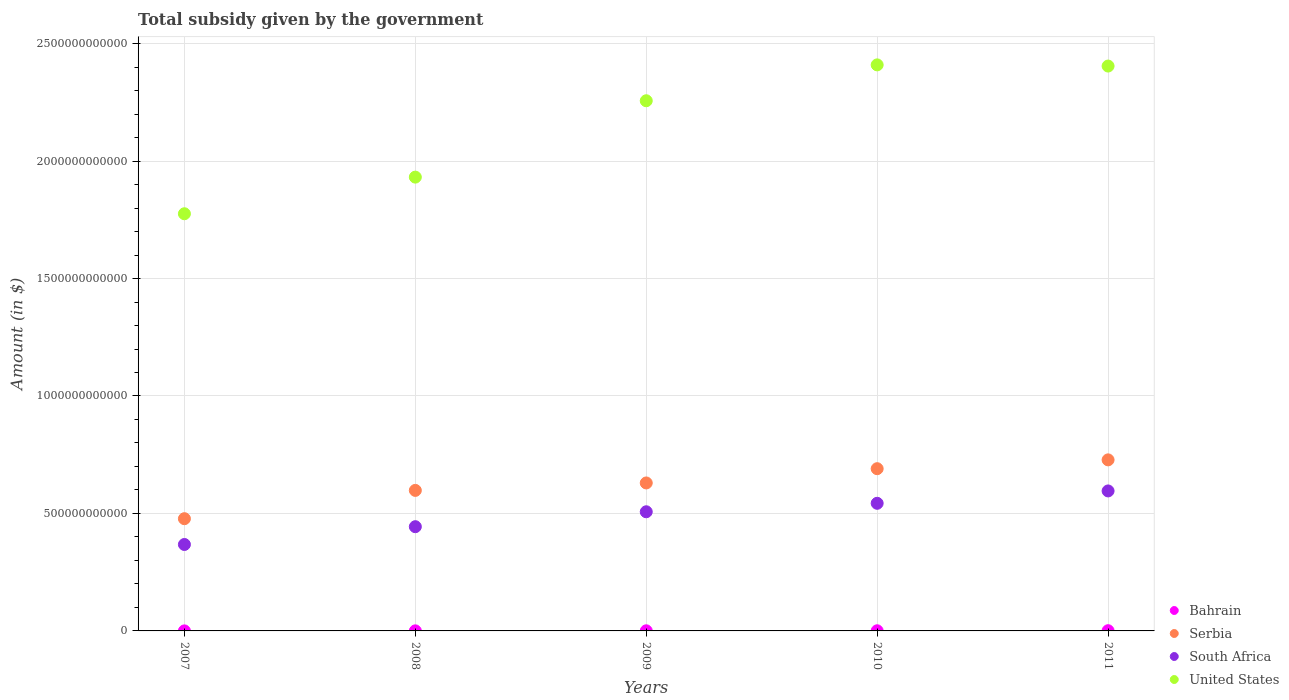Is the number of dotlines equal to the number of legend labels?
Provide a succinct answer. Yes. What is the total revenue collected by the government in Bahrain in 2007?
Offer a very short reply. 1.33e+08. Across all years, what is the maximum total revenue collected by the government in Bahrain?
Provide a short and direct response. 9.39e+08. Across all years, what is the minimum total revenue collected by the government in Serbia?
Ensure brevity in your answer.  4.78e+11. In which year was the total revenue collected by the government in United States maximum?
Keep it short and to the point. 2010. In which year was the total revenue collected by the government in South Africa minimum?
Provide a short and direct response. 2007. What is the total total revenue collected by the government in Serbia in the graph?
Your response must be concise. 3.12e+12. What is the difference between the total revenue collected by the government in Bahrain in 2007 and that in 2011?
Provide a short and direct response. -8.07e+08. What is the difference between the total revenue collected by the government in United States in 2010 and the total revenue collected by the government in Serbia in 2008?
Provide a short and direct response. 1.81e+12. What is the average total revenue collected by the government in United States per year?
Keep it short and to the point. 2.16e+12. In the year 2011, what is the difference between the total revenue collected by the government in South Africa and total revenue collected by the government in United States?
Provide a short and direct response. -1.81e+12. In how many years, is the total revenue collected by the government in South Africa greater than 900000000000 $?
Offer a terse response. 0. What is the ratio of the total revenue collected by the government in South Africa in 2007 to that in 2011?
Offer a very short reply. 0.62. Is the total revenue collected by the government in United States in 2007 less than that in 2011?
Your answer should be very brief. Yes. What is the difference between the highest and the lowest total revenue collected by the government in Bahrain?
Your answer should be very brief. 8.07e+08. Is the sum of the total revenue collected by the government in Bahrain in 2007 and 2010 greater than the maximum total revenue collected by the government in United States across all years?
Provide a succinct answer. No. Is the total revenue collected by the government in United States strictly less than the total revenue collected by the government in Serbia over the years?
Give a very brief answer. No. How many dotlines are there?
Your answer should be very brief. 4. What is the difference between two consecutive major ticks on the Y-axis?
Keep it short and to the point. 5.00e+11. Are the values on the major ticks of Y-axis written in scientific E-notation?
Offer a terse response. No. Does the graph contain any zero values?
Offer a terse response. No. Does the graph contain grids?
Give a very brief answer. Yes. Where does the legend appear in the graph?
Your answer should be very brief. Bottom right. How are the legend labels stacked?
Make the answer very short. Vertical. What is the title of the graph?
Provide a short and direct response. Total subsidy given by the government. Does "Kosovo" appear as one of the legend labels in the graph?
Your answer should be very brief. No. What is the label or title of the X-axis?
Offer a terse response. Years. What is the label or title of the Y-axis?
Your answer should be compact. Amount (in $). What is the Amount (in $) of Bahrain in 2007?
Ensure brevity in your answer.  1.33e+08. What is the Amount (in $) in Serbia in 2007?
Make the answer very short. 4.78e+11. What is the Amount (in $) in South Africa in 2007?
Your answer should be compact. 3.68e+11. What is the Amount (in $) in United States in 2007?
Offer a very short reply. 1.78e+12. What is the Amount (in $) of Bahrain in 2008?
Provide a short and direct response. 3.10e+08. What is the Amount (in $) in Serbia in 2008?
Make the answer very short. 5.98e+11. What is the Amount (in $) in South Africa in 2008?
Offer a very short reply. 4.44e+11. What is the Amount (in $) in United States in 2008?
Make the answer very short. 1.93e+12. What is the Amount (in $) in Bahrain in 2009?
Provide a short and direct response. 5.10e+08. What is the Amount (in $) in Serbia in 2009?
Keep it short and to the point. 6.30e+11. What is the Amount (in $) of South Africa in 2009?
Offer a terse response. 5.07e+11. What is the Amount (in $) of United States in 2009?
Offer a very short reply. 2.26e+12. What is the Amount (in $) of Bahrain in 2010?
Offer a terse response. 6.04e+08. What is the Amount (in $) in Serbia in 2010?
Your answer should be compact. 6.91e+11. What is the Amount (in $) of South Africa in 2010?
Your answer should be compact. 5.43e+11. What is the Amount (in $) of United States in 2010?
Make the answer very short. 2.41e+12. What is the Amount (in $) in Bahrain in 2011?
Your answer should be very brief. 9.39e+08. What is the Amount (in $) of Serbia in 2011?
Offer a terse response. 7.28e+11. What is the Amount (in $) in South Africa in 2011?
Ensure brevity in your answer.  5.96e+11. What is the Amount (in $) of United States in 2011?
Your response must be concise. 2.40e+12. Across all years, what is the maximum Amount (in $) of Bahrain?
Offer a very short reply. 9.39e+08. Across all years, what is the maximum Amount (in $) of Serbia?
Make the answer very short. 7.28e+11. Across all years, what is the maximum Amount (in $) of South Africa?
Provide a succinct answer. 5.96e+11. Across all years, what is the maximum Amount (in $) of United States?
Offer a very short reply. 2.41e+12. Across all years, what is the minimum Amount (in $) of Bahrain?
Keep it short and to the point. 1.33e+08. Across all years, what is the minimum Amount (in $) of Serbia?
Give a very brief answer. 4.78e+11. Across all years, what is the minimum Amount (in $) in South Africa?
Provide a succinct answer. 3.68e+11. Across all years, what is the minimum Amount (in $) of United States?
Ensure brevity in your answer.  1.78e+12. What is the total Amount (in $) of Bahrain in the graph?
Provide a short and direct response. 2.50e+09. What is the total Amount (in $) in Serbia in the graph?
Provide a short and direct response. 3.12e+12. What is the total Amount (in $) of South Africa in the graph?
Ensure brevity in your answer.  2.46e+12. What is the total Amount (in $) in United States in the graph?
Your answer should be compact. 1.08e+13. What is the difference between the Amount (in $) in Bahrain in 2007 and that in 2008?
Your answer should be compact. -1.78e+08. What is the difference between the Amount (in $) in Serbia in 2007 and that in 2008?
Your answer should be very brief. -1.20e+11. What is the difference between the Amount (in $) of South Africa in 2007 and that in 2008?
Ensure brevity in your answer.  -7.57e+1. What is the difference between the Amount (in $) of United States in 2007 and that in 2008?
Your answer should be compact. -1.56e+11. What is the difference between the Amount (in $) in Bahrain in 2007 and that in 2009?
Your answer should be very brief. -3.78e+08. What is the difference between the Amount (in $) in Serbia in 2007 and that in 2009?
Provide a succinct answer. -1.52e+11. What is the difference between the Amount (in $) of South Africa in 2007 and that in 2009?
Your response must be concise. -1.39e+11. What is the difference between the Amount (in $) in United States in 2007 and that in 2009?
Offer a very short reply. -4.81e+11. What is the difference between the Amount (in $) in Bahrain in 2007 and that in 2010?
Ensure brevity in your answer.  -4.71e+08. What is the difference between the Amount (in $) in Serbia in 2007 and that in 2010?
Your response must be concise. -2.13e+11. What is the difference between the Amount (in $) in South Africa in 2007 and that in 2010?
Give a very brief answer. -1.75e+11. What is the difference between the Amount (in $) in United States in 2007 and that in 2010?
Your answer should be very brief. -6.34e+11. What is the difference between the Amount (in $) in Bahrain in 2007 and that in 2011?
Your answer should be compact. -8.07e+08. What is the difference between the Amount (in $) of Serbia in 2007 and that in 2011?
Offer a very short reply. -2.50e+11. What is the difference between the Amount (in $) of South Africa in 2007 and that in 2011?
Your answer should be compact. -2.28e+11. What is the difference between the Amount (in $) of United States in 2007 and that in 2011?
Your response must be concise. -6.29e+11. What is the difference between the Amount (in $) in Bahrain in 2008 and that in 2009?
Your answer should be compact. -2.00e+08. What is the difference between the Amount (in $) of Serbia in 2008 and that in 2009?
Ensure brevity in your answer.  -3.17e+1. What is the difference between the Amount (in $) in South Africa in 2008 and that in 2009?
Keep it short and to the point. -6.35e+1. What is the difference between the Amount (in $) of United States in 2008 and that in 2009?
Offer a terse response. -3.25e+11. What is the difference between the Amount (in $) of Bahrain in 2008 and that in 2010?
Give a very brief answer. -2.94e+08. What is the difference between the Amount (in $) of Serbia in 2008 and that in 2010?
Make the answer very short. -9.24e+1. What is the difference between the Amount (in $) in South Africa in 2008 and that in 2010?
Provide a succinct answer. -9.96e+1. What is the difference between the Amount (in $) in United States in 2008 and that in 2010?
Give a very brief answer. -4.78e+11. What is the difference between the Amount (in $) in Bahrain in 2008 and that in 2011?
Make the answer very short. -6.29e+08. What is the difference between the Amount (in $) of Serbia in 2008 and that in 2011?
Your answer should be compact. -1.30e+11. What is the difference between the Amount (in $) of South Africa in 2008 and that in 2011?
Provide a short and direct response. -1.52e+11. What is the difference between the Amount (in $) of United States in 2008 and that in 2011?
Make the answer very short. -4.73e+11. What is the difference between the Amount (in $) of Bahrain in 2009 and that in 2010?
Give a very brief answer. -9.36e+07. What is the difference between the Amount (in $) in Serbia in 2009 and that in 2010?
Ensure brevity in your answer.  -6.07e+1. What is the difference between the Amount (in $) of South Africa in 2009 and that in 2010?
Give a very brief answer. -3.61e+1. What is the difference between the Amount (in $) of United States in 2009 and that in 2010?
Offer a terse response. -1.53e+11. What is the difference between the Amount (in $) of Bahrain in 2009 and that in 2011?
Keep it short and to the point. -4.29e+08. What is the difference between the Amount (in $) of Serbia in 2009 and that in 2011?
Provide a succinct answer. -9.83e+1. What is the difference between the Amount (in $) in South Africa in 2009 and that in 2011?
Your answer should be very brief. -8.87e+1. What is the difference between the Amount (in $) of United States in 2009 and that in 2011?
Keep it short and to the point. -1.48e+11. What is the difference between the Amount (in $) in Bahrain in 2010 and that in 2011?
Provide a short and direct response. -3.35e+08. What is the difference between the Amount (in $) in Serbia in 2010 and that in 2011?
Your answer should be compact. -3.75e+1. What is the difference between the Amount (in $) of South Africa in 2010 and that in 2011?
Offer a very short reply. -5.26e+1. What is the difference between the Amount (in $) in United States in 2010 and that in 2011?
Offer a very short reply. 5.00e+09. What is the difference between the Amount (in $) of Bahrain in 2007 and the Amount (in $) of Serbia in 2008?
Provide a short and direct response. -5.98e+11. What is the difference between the Amount (in $) of Bahrain in 2007 and the Amount (in $) of South Africa in 2008?
Your response must be concise. -4.44e+11. What is the difference between the Amount (in $) in Bahrain in 2007 and the Amount (in $) in United States in 2008?
Keep it short and to the point. -1.93e+12. What is the difference between the Amount (in $) of Serbia in 2007 and the Amount (in $) of South Africa in 2008?
Give a very brief answer. 3.41e+1. What is the difference between the Amount (in $) of Serbia in 2007 and the Amount (in $) of United States in 2008?
Give a very brief answer. -1.45e+12. What is the difference between the Amount (in $) of South Africa in 2007 and the Amount (in $) of United States in 2008?
Keep it short and to the point. -1.56e+12. What is the difference between the Amount (in $) in Bahrain in 2007 and the Amount (in $) in Serbia in 2009?
Provide a short and direct response. -6.30e+11. What is the difference between the Amount (in $) of Bahrain in 2007 and the Amount (in $) of South Africa in 2009?
Provide a short and direct response. -5.07e+11. What is the difference between the Amount (in $) in Bahrain in 2007 and the Amount (in $) in United States in 2009?
Provide a short and direct response. -2.26e+12. What is the difference between the Amount (in $) of Serbia in 2007 and the Amount (in $) of South Africa in 2009?
Your response must be concise. -2.94e+1. What is the difference between the Amount (in $) in Serbia in 2007 and the Amount (in $) in United States in 2009?
Make the answer very short. -1.78e+12. What is the difference between the Amount (in $) in South Africa in 2007 and the Amount (in $) in United States in 2009?
Your response must be concise. -1.89e+12. What is the difference between the Amount (in $) in Bahrain in 2007 and the Amount (in $) in Serbia in 2010?
Your answer should be compact. -6.90e+11. What is the difference between the Amount (in $) in Bahrain in 2007 and the Amount (in $) in South Africa in 2010?
Ensure brevity in your answer.  -5.43e+11. What is the difference between the Amount (in $) in Bahrain in 2007 and the Amount (in $) in United States in 2010?
Your answer should be compact. -2.41e+12. What is the difference between the Amount (in $) of Serbia in 2007 and the Amount (in $) of South Africa in 2010?
Offer a very short reply. -6.55e+1. What is the difference between the Amount (in $) of Serbia in 2007 and the Amount (in $) of United States in 2010?
Provide a succinct answer. -1.93e+12. What is the difference between the Amount (in $) in South Africa in 2007 and the Amount (in $) in United States in 2010?
Make the answer very short. -2.04e+12. What is the difference between the Amount (in $) of Bahrain in 2007 and the Amount (in $) of Serbia in 2011?
Your answer should be very brief. -7.28e+11. What is the difference between the Amount (in $) of Bahrain in 2007 and the Amount (in $) of South Africa in 2011?
Make the answer very short. -5.96e+11. What is the difference between the Amount (in $) in Bahrain in 2007 and the Amount (in $) in United States in 2011?
Provide a short and direct response. -2.40e+12. What is the difference between the Amount (in $) of Serbia in 2007 and the Amount (in $) of South Africa in 2011?
Provide a succinct answer. -1.18e+11. What is the difference between the Amount (in $) in Serbia in 2007 and the Amount (in $) in United States in 2011?
Your response must be concise. -1.93e+12. What is the difference between the Amount (in $) in South Africa in 2007 and the Amount (in $) in United States in 2011?
Keep it short and to the point. -2.04e+12. What is the difference between the Amount (in $) in Bahrain in 2008 and the Amount (in $) in Serbia in 2009?
Give a very brief answer. -6.30e+11. What is the difference between the Amount (in $) in Bahrain in 2008 and the Amount (in $) in South Africa in 2009?
Ensure brevity in your answer.  -5.07e+11. What is the difference between the Amount (in $) in Bahrain in 2008 and the Amount (in $) in United States in 2009?
Keep it short and to the point. -2.26e+12. What is the difference between the Amount (in $) of Serbia in 2008 and the Amount (in $) of South Africa in 2009?
Give a very brief answer. 9.10e+1. What is the difference between the Amount (in $) of Serbia in 2008 and the Amount (in $) of United States in 2009?
Provide a short and direct response. -1.66e+12. What is the difference between the Amount (in $) of South Africa in 2008 and the Amount (in $) of United States in 2009?
Keep it short and to the point. -1.81e+12. What is the difference between the Amount (in $) in Bahrain in 2008 and the Amount (in $) in Serbia in 2010?
Give a very brief answer. -6.90e+11. What is the difference between the Amount (in $) in Bahrain in 2008 and the Amount (in $) in South Africa in 2010?
Give a very brief answer. -5.43e+11. What is the difference between the Amount (in $) in Bahrain in 2008 and the Amount (in $) in United States in 2010?
Provide a succinct answer. -2.41e+12. What is the difference between the Amount (in $) of Serbia in 2008 and the Amount (in $) of South Africa in 2010?
Your response must be concise. 5.49e+1. What is the difference between the Amount (in $) in Serbia in 2008 and the Amount (in $) in United States in 2010?
Ensure brevity in your answer.  -1.81e+12. What is the difference between the Amount (in $) in South Africa in 2008 and the Amount (in $) in United States in 2010?
Your answer should be compact. -1.97e+12. What is the difference between the Amount (in $) of Bahrain in 2008 and the Amount (in $) of Serbia in 2011?
Your answer should be compact. -7.28e+11. What is the difference between the Amount (in $) of Bahrain in 2008 and the Amount (in $) of South Africa in 2011?
Offer a terse response. -5.96e+11. What is the difference between the Amount (in $) of Bahrain in 2008 and the Amount (in $) of United States in 2011?
Keep it short and to the point. -2.40e+12. What is the difference between the Amount (in $) of Serbia in 2008 and the Amount (in $) of South Africa in 2011?
Your response must be concise. 2.31e+09. What is the difference between the Amount (in $) in Serbia in 2008 and the Amount (in $) in United States in 2011?
Make the answer very short. -1.81e+12. What is the difference between the Amount (in $) in South Africa in 2008 and the Amount (in $) in United States in 2011?
Keep it short and to the point. -1.96e+12. What is the difference between the Amount (in $) in Bahrain in 2009 and the Amount (in $) in Serbia in 2010?
Offer a terse response. -6.90e+11. What is the difference between the Amount (in $) in Bahrain in 2009 and the Amount (in $) in South Africa in 2010?
Provide a succinct answer. -5.43e+11. What is the difference between the Amount (in $) of Bahrain in 2009 and the Amount (in $) of United States in 2010?
Your answer should be compact. -2.41e+12. What is the difference between the Amount (in $) in Serbia in 2009 and the Amount (in $) in South Africa in 2010?
Offer a terse response. 8.66e+1. What is the difference between the Amount (in $) in Serbia in 2009 and the Amount (in $) in United States in 2010?
Make the answer very short. -1.78e+12. What is the difference between the Amount (in $) in South Africa in 2009 and the Amount (in $) in United States in 2010?
Offer a terse response. -1.90e+12. What is the difference between the Amount (in $) in Bahrain in 2009 and the Amount (in $) in Serbia in 2011?
Make the answer very short. -7.28e+11. What is the difference between the Amount (in $) of Bahrain in 2009 and the Amount (in $) of South Africa in 2011?
Make the answer very short. -5.95e+11. What is the difference between the Amount (in $) of Bahrain in 2009 and the Amount (in $) of United States in 2011?
Your answer should be very brief. -2.40e+12. What is the difference between the Amount (in $) of Serbia in 2009 and the Amount (in $) of South Africa in 2011?
Provide a succinct answer. 3.40e+1. What is the difference between the Amount (in $) of Serbia in 2009 and the Amount (in $) of United States in 2011?
Keep it short and to the point. -1.77e+12. What is the difference between the Amount (in $) of South Africa in 2009 and the Amount (in $) of United States in 2011?
Offer a very short reply. -1.90e+12. What is the difference between the Amount (in $) of Bahrain in 2010 and the Amount (in $) of Serbia in 2011?
Offer a terse response. -7.27e+11. What is the difference between the Amount (in $) of Bahrain in 2010 and the Amount (in $) of South Africa in 2011?
Ensure brevity in your answer.  -5.95e+11. What is the difference between the Amount (in $) of Bahrain in 2010 and the Amount (in $) of United States in 2011?
Keep it short and to the point. -2.40e+12. What is the difference between the Amount (in $) of Serbia in 2010 and the Amount (in $) of South Africa in 2011?
Offer a very short reply. 9.47e+1. What is the difference between the Amount (in $) in Serbia in 2010 and the Amount (in $) in United States in 2011?
Offer a terse response. -1.71e+12. What is the difference between the Amount (in $) of South Africa in 2010 and the Amount (in $) of United States in 2011?
Provide a succinct answer. -1.86e+12. What is the average Amount (in $) of Bahrain per year?
Offer a terse response. 4.99e+08. What is the average Amount (in $) in Serbia per year?
Your response must be concise. 6.25e+11. What is the average Amount (in $) of South Africa per year?
Make the answer very short. 4.92e+11. What is the average Amount (in $) of United States per year?
Keep it short and to the point. 2.16e+12. In the year 2007, what is the difference between the Amount (in $) of Bahrain and Amount (in $) of Serbia?
Provide a succinct answer. -4.78e+11. In the year 2007, what is the difference between the Amount (in $) of Bahrain and Amount (in $) of South Africa?
Give a very brief answer. -3.68e+11. In the year 2007, what is the difference between the Amount (in $) in Bahrain and Amount (in $) in United States?
Keep it short and to the point. -1.78e+12. In the year 2007, what is the difference between the Amount (in $) in Serbia and Amount (in $) in South Africa?
Your response must be concise. 1.10e+11. In the year 2007, what is the difference between the Amount (in $) of Serbia and Amount (in $) of United States?
Provide a short and direct response. -1.30e+12. In the year 2007, what is the difference between the Amount (in $) of South Africa and Amount (in $) of United States?
Ensure brevity in your answer.  -1.41e+12. In the year 2008, what is the difference between the Amount (in $) in Bahrain and Amount (in $) in Serbia?
Provide a succinct answer. -5.98e+11. In the year 2008, what is the difference between the Amount (in $) in Bahrain and Amount (in $) in South Africa?
Give a very brief answer. -4.43e+11. In the year 2008, what is the difference between the Amount (in $) in Bahrain and Amount (in $) in United States?
Offer a terse response. -1.93e+12. In the year 2008, what is the difference between the Amount (in $) of Serbia and Amount (in $) of South Africa?
Make the answer very short. 1.55e+11. In the year 2008, what is the difference between the Amount (in $) in Serbia and Amount (in $) in United States?
Your answer should be compact. -1.33e+12. In the year 2008, what is the difference between the Amount (in $) of South Africa and Amount (in $) of United States?
Ensure brevity in your answer.  -1.49e+12. In the year 2009, what is the difference between the Amount (in $) of Bahrain and Amount (in $) of Serbia?
Offer a very short reply. -6.29e+11. In the year 2009, what is the difference between the Amount (in $) of Bahrain and Amount (in $) of South Africa?
Your answer should be compact. -5.07e+11. In the year 2009, what is the difference between the Amount (in $) of Bahrain and Amount (in $) of United States?
Provide a succinct answer. -2.26e+12. In the year 2009, what is the difference between the Amount (in $) in Serbia and Amount (in $) in South Africa?
Your response must be concise. 1.23e+11. In the year 2009, what is the difference between the Amount (in $) of Serbia and Amount (in $) of United States?
Offer a very short reply. -1.63e+12. In the year 2009, what is the difference between the Amount (in $) in South Africa and Amount (in $) in United States?
Offer a very short reply. -1.75e+12. In the year 2010, what is the difference between the Amount (in $) in Bahrain and Amount (in $) in Serbia?
Provide a short and direct response. -6.90e+11. In the year 2010, what is the difference between the Amount (in $) of Bahrain and Amount (in $) of South Africa?
Provide a succinct answer. -5.43e+11. In the year 2010, what is the difference between the Amount (in $) in Bahrain and Amount (in $) in United States?
Ensure brevity in your answer.  -2.41e+12. In the year 2010, what is the difference between the Amount (in $) in Serbia and Amount (in $) in South Africa?
Your answer should be very brief. 1.47e+11. In the year 2010, what is the difference between the Amount (in $) in Serbia and Amount (in $) in United States?
Ensure brevity in your answer.  -1.72e+12. In the year 2010, what is the difference between the Amount (in $) of South Africa and Amount (in $) of United States?
Offer a terse response. -1.87e+12. In the year 2011, what is the difference between the Amount (in $) in Bahrain and Amount (in $) in Serbia?
Your answer should be compact. -7.27e+11. In the year 2011, what is the difference between the Amount (in $) in Bahrain and Amount (in $) in South Africa?
Keep it short and to the point. -5.95e+11. In the year 2011, what is the difference between the Amount (in $) of Bahrain and Amount (in $) of United States?
Your answer should be very brief. -2.40e+12. In the year 2011, what is the difference between the Amount (in $) of Serbia and Amount (in $) of South Africa?
Offer a very short reply. 1.32e+11. In the year 2011, what is the difference between the Amount (in $) in Serbia and Amount (in $) in United States?
Offer a terse response. -1.68e+12. In the year 2011, what is the difference between the Amount (in $) of South Africa and Amount (in $) of United States?
Give a very brief answer. -1.81e+12. What is the ratio of the Amount (in $) in Bahrain in 2007 to that in 2008?
Your response must be concise. 0.43. What is the ratio of the Amount (in $) of Serbia in 2007 to that in 2008?
Offer a very short reply. 0.8. What is the ratio of the Amount (in $) of South Africa in 2007 to that in 2008?
Offer a terse response. 0.83. What is the ratio of the Amount (in $) in United States in 2007 to that in 2008?
Your answer should be very brief. 0.92. What is the ratio of the Amount (in $) in Bahrain in 2007 to that in 2009?
Keep it short and to the point. 0.26. What is the ratio of the Amount (in $) in Serbia in 2007 to that in 2009?
Offer a very short reply. 0.76. What is the ratio of the Amount (in $) in South Africa in 2007 to that in 2009?
Offer a terse response. 0.73. What is the ratio of the Amount (in $) of United States in 2007 to that in 2009?
Provide a short and direct response. 0.79. What is the ratio of the Amount (in $) of Bahrain in 2007 to that in 2010?
Provide a succinct answer. 0.22. What is the ratio of the Amount (in $) in Serbia in 2007 to that in 2010?
Make the answer very short. 0.69. What is the ratio of the Amount (in $) of South Africa in 2007 to that in 2010?
Offer a very short reply. 0.68. What is the ratio of the Amount (in $) in United States in 2007 to that in 2010?
Keep it short and to the point. 0.74. What is the ratio of the Amount (in $) of Bahrain in 2007 to that in 2011?
Ensure brevity in your answer.  0.14. What is the ratio of the Amount (in $) of Serbia in 2007 to that in 2011?
Provide a short and direct response. 0.66. What is the ratio of the Amount (in $) of South Africa in 2007 to that in 2011?
Offer a very short reply. 0.62. What is the ratio of the Amount (in $) in United States in 2007 to that in 2011?
Your answer should be compact. 0.74. What is the ratio of the Amount (in $) of Bahrain in 2008 to that in 2009?
Provide a short and direct response. 0.61. What is the ratio of the Amount (in $) in Serbia in 2008 to that in 2009?
Provide a short and direct response. 0.95. What is the ratio of the Amount (in $) of South Africa in 2008 to that in 2009?
Your response must be concise. 0.87. What is the ratio of the Amount (in $) in United States in 2008 to that in 2009?
Keep it short and to the point. 0.86. What is the ratio of the Amount (in $) in Bahrain in 2008 to that in 2010?
Keep it short and to the point. 0.51. What is the ratio of the Amount (in $) of Serbia in 2008 to that in 2010?
Ensure brevity in your answer.  0.87. What is the ratio of the Amount (in $) in South Africa in 2008 to that in 2010?
Offer a very short reply. 0.82. What is the ratio of the Amount (in $) in United States in 2008 to that in 2010?
Your response must be concise. 0.8. What is the ratio of the Amount (in $) of Bahrain in 2008 to that in 2011?
Your response must be concise. 0.33. What is the ratio of the Amount (in $) in Serbia in 2008 to that in 2011?
Offer a terse response. 0.82. What is the ratio of the Amount (in $) of South Africa in 2008 to that in 2011?
Make the answer very short. 0.74. What is the ratio of the Amount (in $) in United States in 2008 to that in 2011?
Your answer should be very brief. 0.8. What is the ratio of the Amount (in $) in Bahrain in 2009 to that in 2010?
Keep it short and to the point. 0.84. What is the ratio of the Amount (in $) of Serbia in 2009 to that in 2010?
Ensure brevity in your answer.  0.91. What is the ratio of the Amount (in $) in South Africa in 2009 to that in 2010?
Provide a short and direct response. 0.93. What is the ratio of the Amount (in $) of United States in 2009 to that in 2010?
Give a very brief answer. 0.94. What is the ratio of the Amount (in $) in Bahrain in 2009 to that in 2011?
Provide a short and direct response. 0.54. What is the ratio of the Amount (in $) of Serbia in 2009 to that in 2011?
Keep it short and to the point. 0.86. What is the ratio of the Amount (in $) of South Africa in 2009 to that in 2011?
Give a very brief answer. 0.85. What is the ratio of the Amount (in $) of United States in 2009 to that in 2011?
Offer a terse response. 0.94. What is the ratio of the Amount (in $) in Bahrain in 2010 to that in 2011?
Offer a terse response. 0.64. What is the ratio of the Amount (in $) of Serbia in 2010 to that in 2011?
Keep it short and to the point. 0.95. What is the ratio of the Amount (in $) in South Africa in 2010 to that in 2011?
Make the answer very short. 0.91. What is the ratio of the Amount (in $) in United States in 2010 to that in 2011?
Provide a succinct answer. 1. What is the difference between the highest and the second highest Amount (in $) of Bahrain?
Make the answer very short. 3.35e+08. What is the difference between the highest and the second highest Amount (in $) in Serbia?
Your response must be concise. 3.75e+1. What is the difference between the highest and the second highest Amount (in $) of South Africa?
Offer a terse response. 5.26e+1. What is the difference between the highest and the lowest Amount (in $) in Bahrain?
Your response must be concise. 8.07e+08. What is the difference between the highest and the lowest Amount (in $) in Serbia?
Keep it short and to the point. 2.50e+11. What is the difference between the highest and the lowest Amount (in $) of South Africa?
Your answer should be compact. 2.28e+11. What is the difference between the highest and the lowest Amount (in $) of United States?
Your answer should be compact. 6.34e+11. 